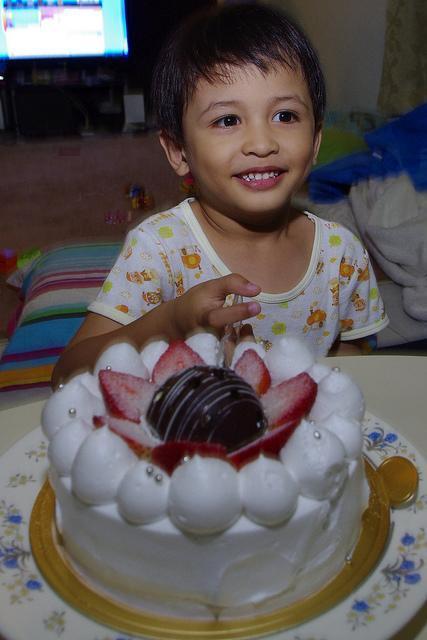How many kids are there?
Give a very brief answer. 1. How many buses are photographed?
Give a very brief answer. 0. 